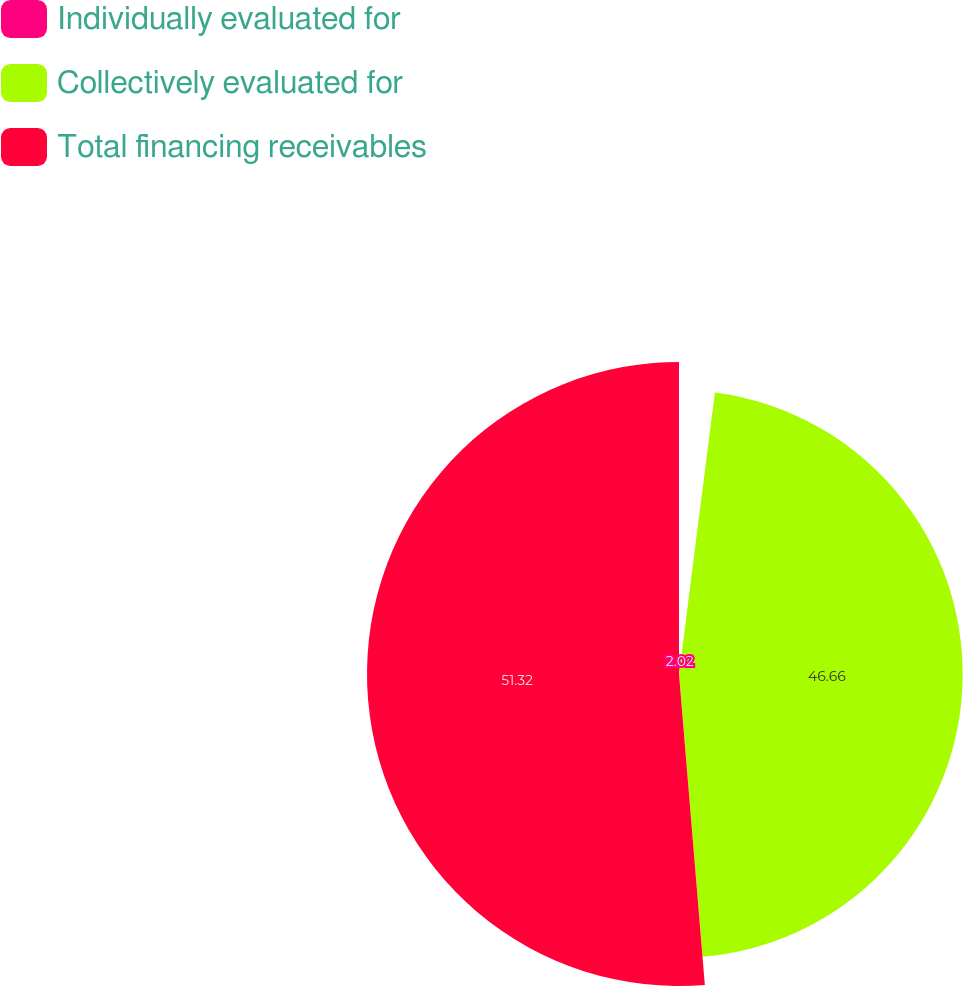<chart> <loc_0><loc_0><loc_500><loc_500><pie_chart><fcel>Individually evaluated for<fcel>Collectively evaluated for<fcel>Total financing receivables<nl><fcel>2.02%<fcel>46.66%<fcel>51.32%<nl></chart> 